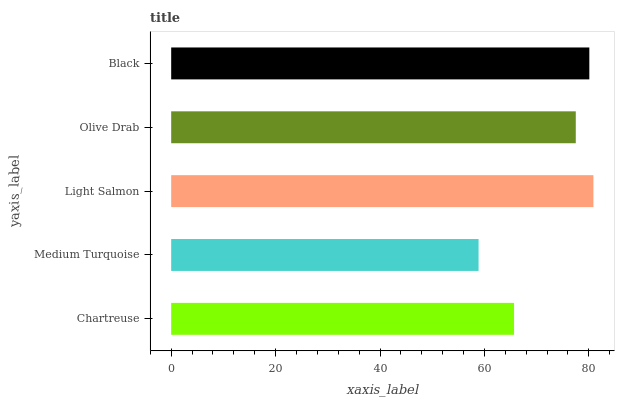Is Medium Turquoise the minimum?
Answer yes or no. Yes. Is Light Salmon the maximum?
Answer yes or no. Yes. Is Light Salmon the minimum?
Answer yes or no. No. Is Medium Turquoise the maximum?
Answer yes or no. No. Is Light Salmon greater than Medium Turquoise?
Answer yes or no. Yes. Is Medium Turquoise less than Light Salmon?
Answer yes or no. Yes. Is Medium Turquoise greater than Light Salmon?
Answer yes or no. No. Is Light Salmon less than Medium Turquoise?
Answer yes or no. No. Is Olive Drab the high median?
Answer yes or no. Yes. Is Olive Drab the low median?
Answer yes or no. Yes. Is Chartreuse the high median?
Answer yes or no. No. Is Light Salmon the low median?
Answer yes or no. No. 